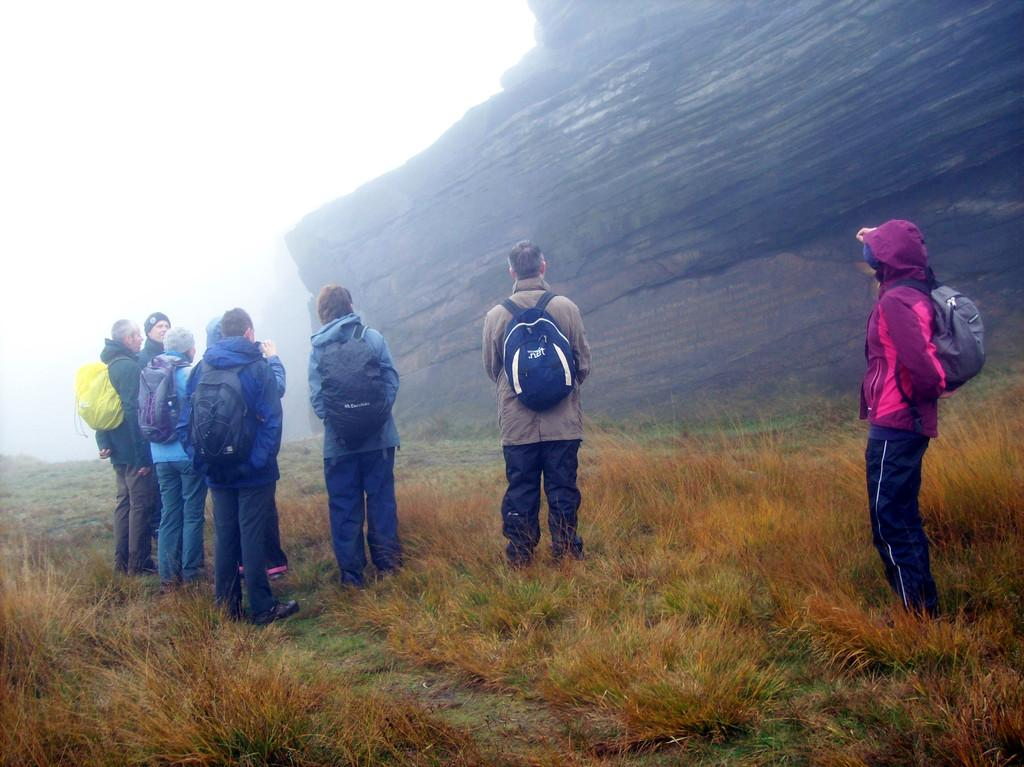Who or what is present in the image? There are people in the image. What are the people carrying on their backs? The people are wearing backpacks. What type of landscape can be seen in the image? There is a mountain in the image, and grass is visible. What part of the natural environment is visible in the image? The sky is visible in the image. What type of quartz can be seen in the image? There is no quartz present in the image. How many clocks are visible in the image? There are no clocks visible in the image. 